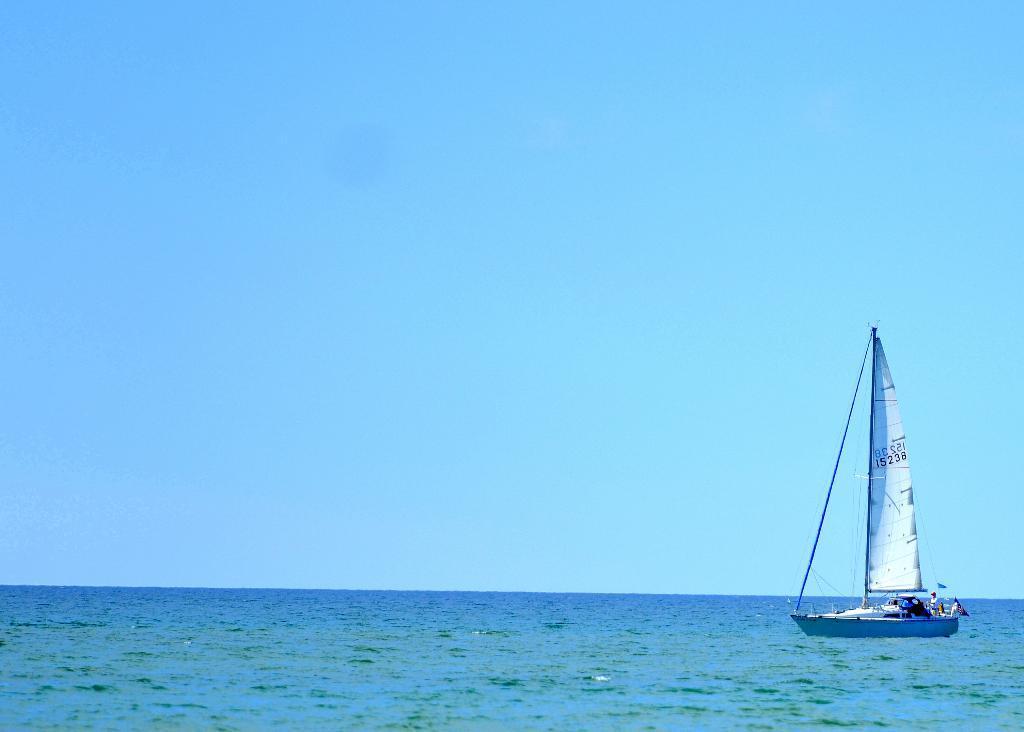How would you summarize this image in a sentence or two? There is a boat on the water. In the back there is sky. 